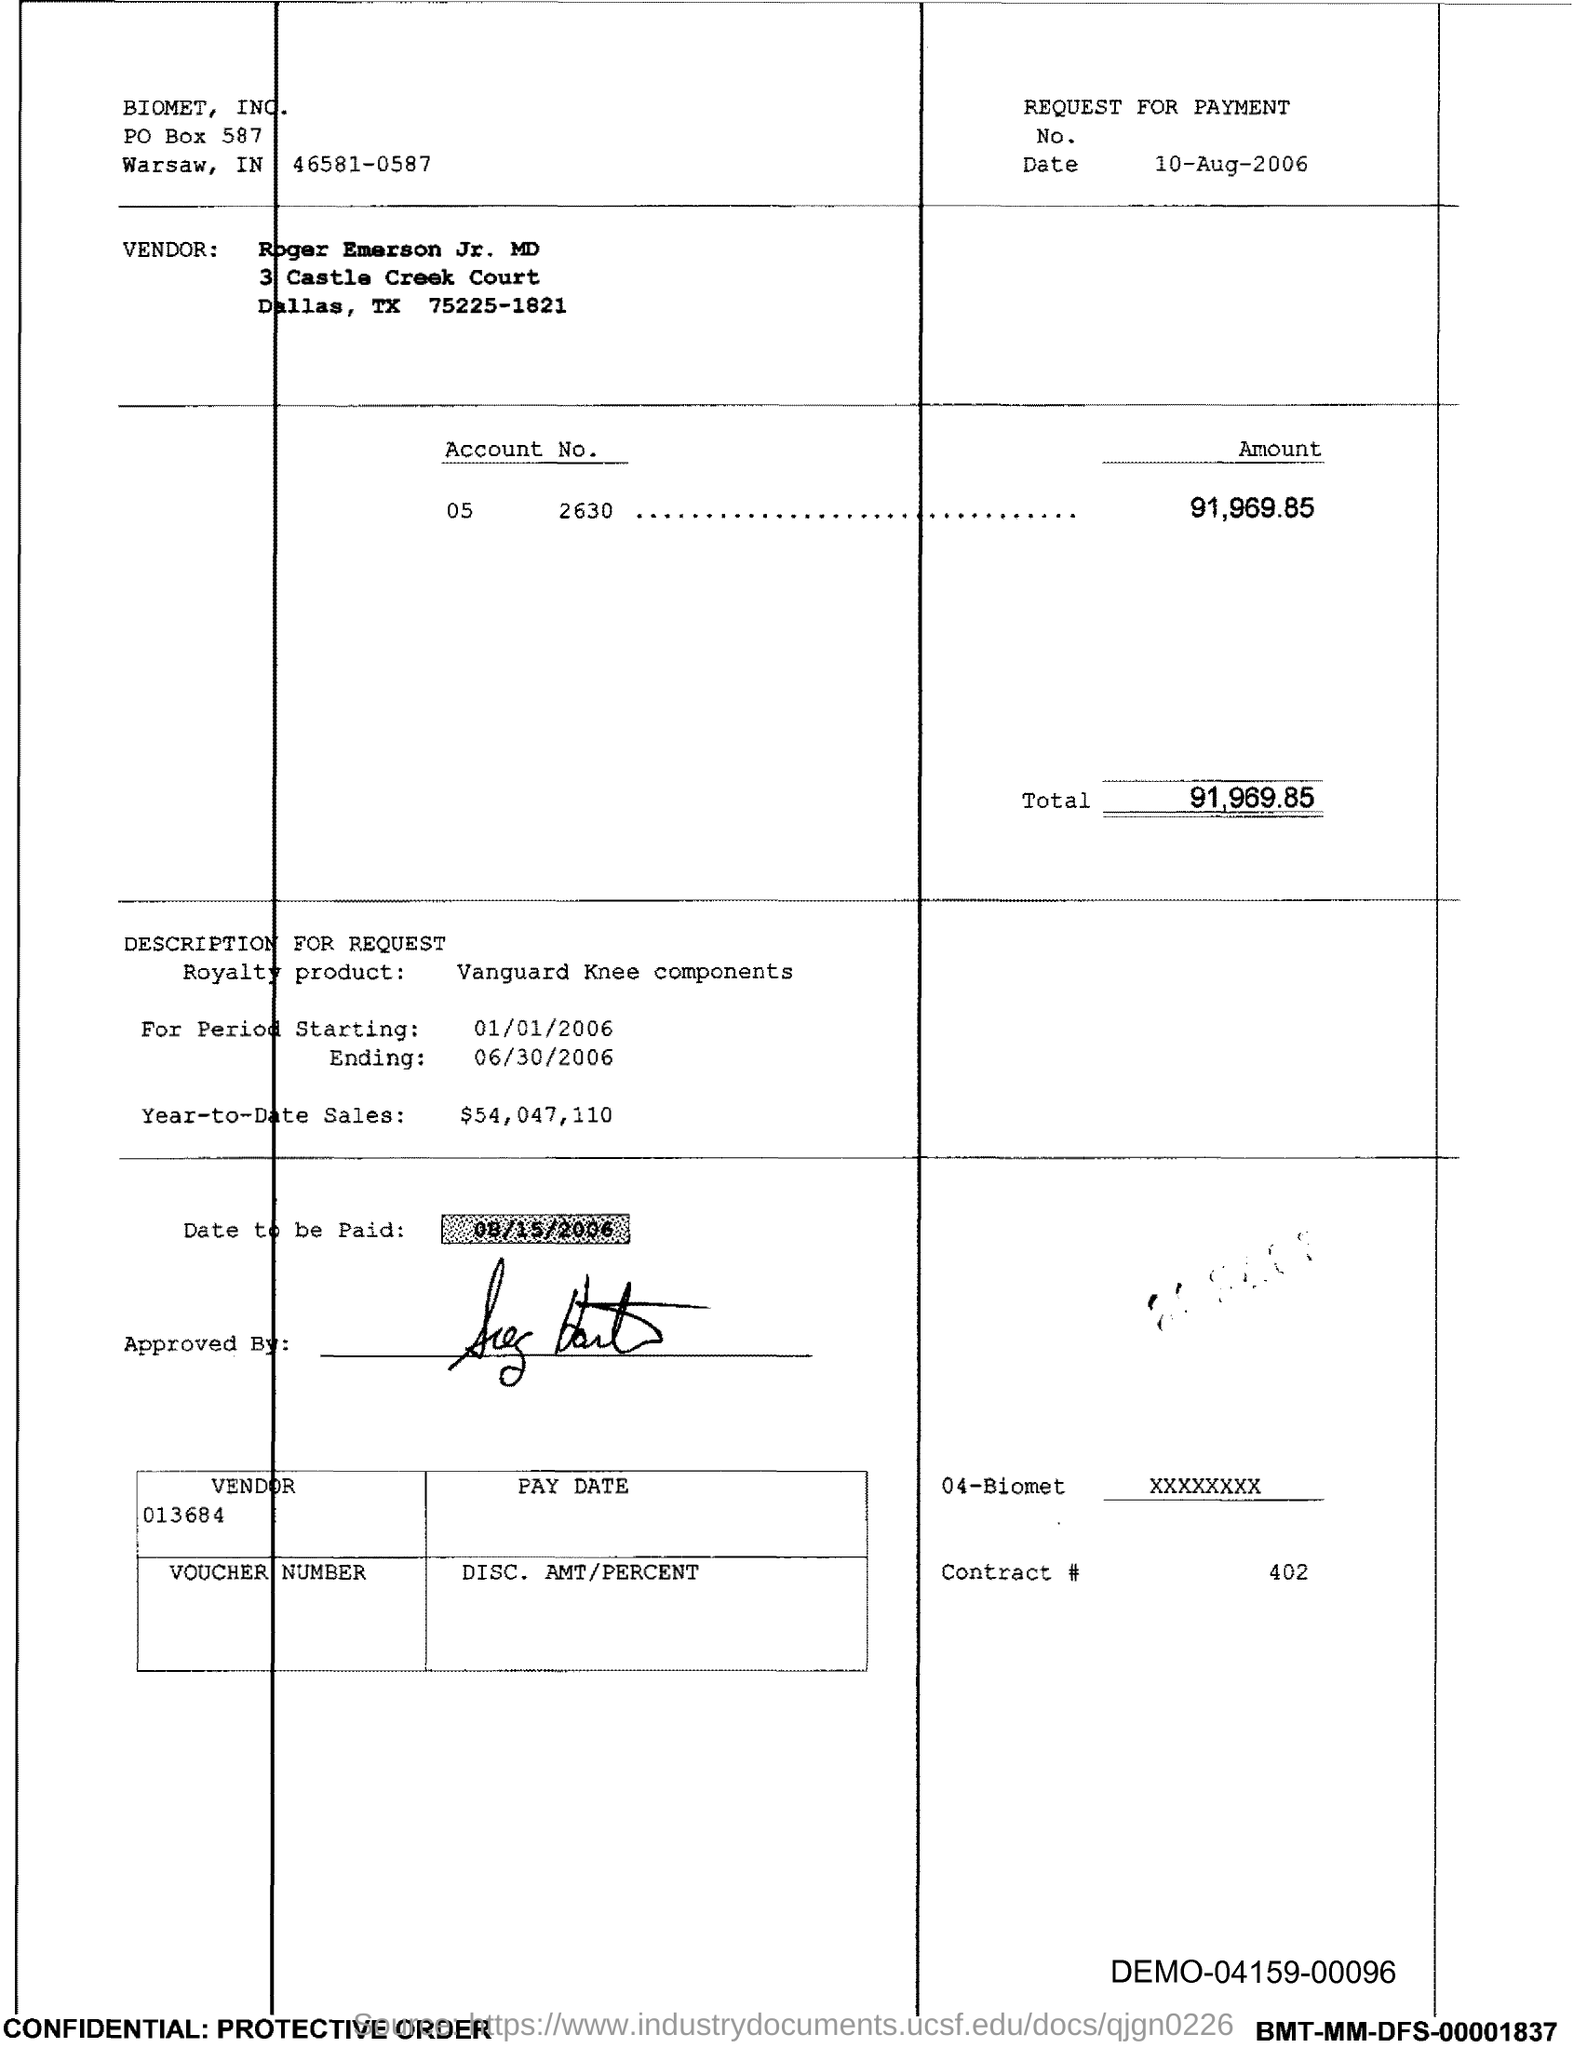What is the document about?
Provide a short and direct response. REQUEST FOR PAYMENT. When is the document dated?
Your answer should be very brief. 10-AUG-2006. What is the amount in the Account No. 05?
Provide a short and direct response. 91,969.85. What is the Royalty product mentioned?
Make the answer very short. Vanguard Knee components. What is the Year-to-Date Sales?
Offer a terse response. $54,047,110. What is the date to be paid?
Your answer should be compact. 08/15/2006. When is the period starting?
Provide a succinct answer. 01/01/2006. 